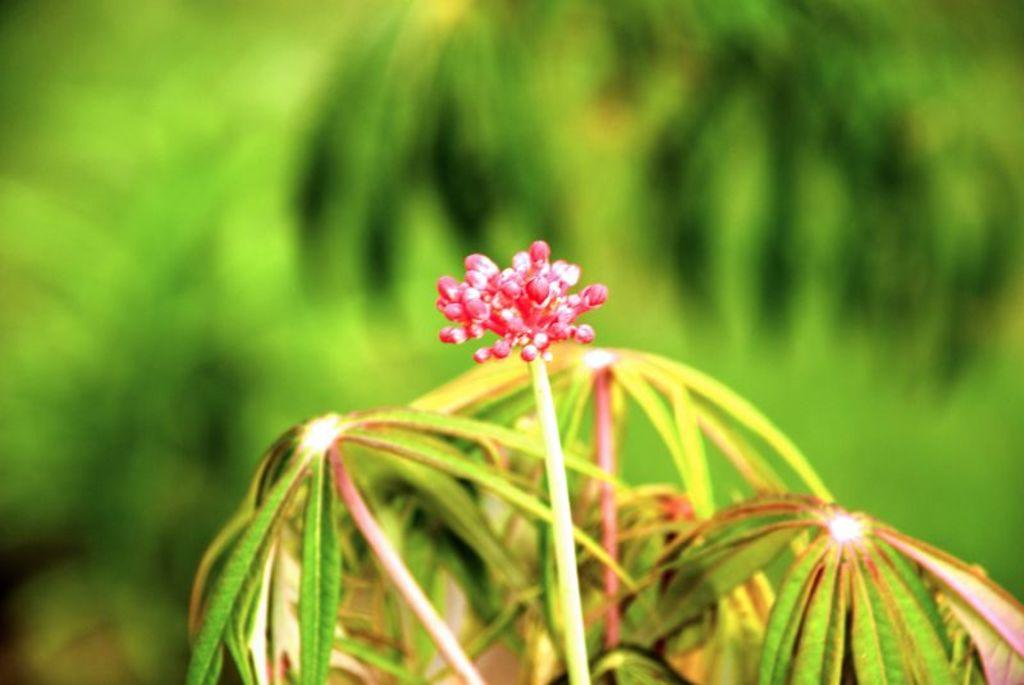What is the main subject of the image? There is a flower in the image. What else can be seen in the image besides the flower? There are leaves in the image. Can you describe the background of the image? The background of the image is blurry. How many babies are crawling on the flower in the image? There are no babies present in the image; it features a flower and leaves. What is the smell of the flower in the image? The image is not accompanied by any smell, so it cannot be determined from the image. 